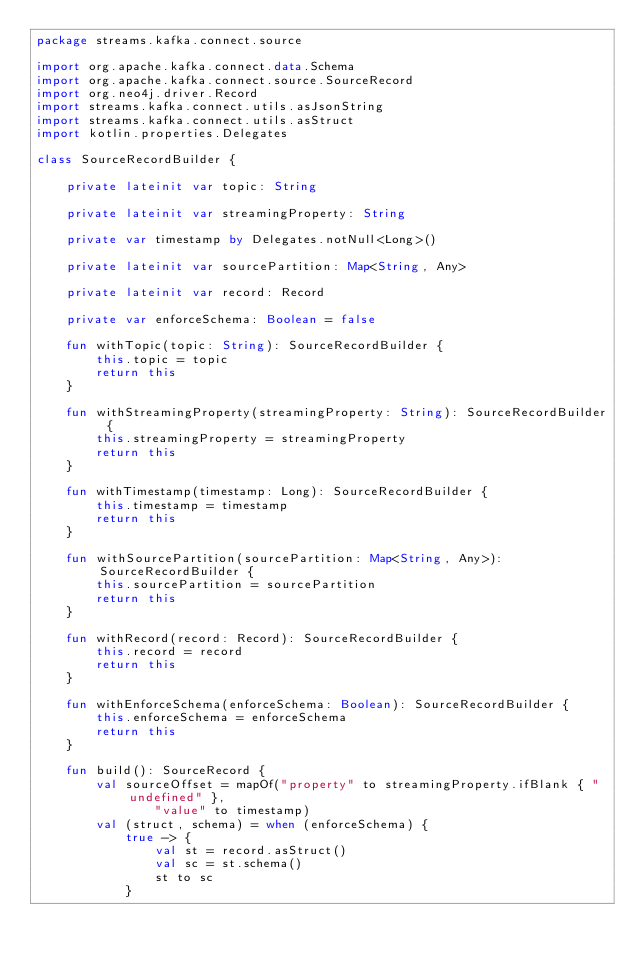<code> <loc_0><loc_0><loc_500><loc_500><_Kotlin_>package streams.kafka.connect.source

import org.apache.kafka.connect.data.Schema
import org.apache.kafka.connect.source.SourceRecord
import org.neo4j.driver.Record
import streams.kafka.connect.utils.asJsonString
import streams.kafka.connect.utils.asStruct
import kotlin.properties.Delegates

class SourceRecordBuilder {

    private lateinit var topic: String

    private lateinit var streamingProperty: String

    private var timestamp by Delegates.notNull<Long>()

    private lateinit var sourcePartition: Map<String, Any>

    private lateinit var record: Record

    private var enforceSchema: Boolean = false

    fun withTopic(topic: String): SourceRecordBuilder {
        this.topic = topic
        return this
    }

    fun withStreamingProperty(streamingProperty: String): SourceRecordBuilder {
        this.streamingProperty = streamingProperty
        return this
    }

    fun withTimestamp(timestamp: Long): SourceRecordBuilder {
        this.timestamp = timestamp
        return this
    }

    fun withSourcePartition(sourcePartition: Map<String, Any>): SourceRecordBuilder {
        this.sourcePartition = sourcePartition
        return this
    }

    fun withRecord(record: Record): SourceRecordBuilder {
        this.record = record
        return this
    }

    fun withEnforceSchema(enforceSchema: Boolean): SourceRecordBuilder {
        this.enforceSchema = enforceSchema
        return this
    }

    fun build(): SourceRecord {
        val sourceOffset = mapOf("property" to streamingProperty.ifBlank { "undefined" },
                "value" to timestamp)
        val (struct, schema) = when (enforceSchema) {
            true -> {
                val st = record.asStruct()
                val sc = st.schema()
                st to sc
            }</code> 